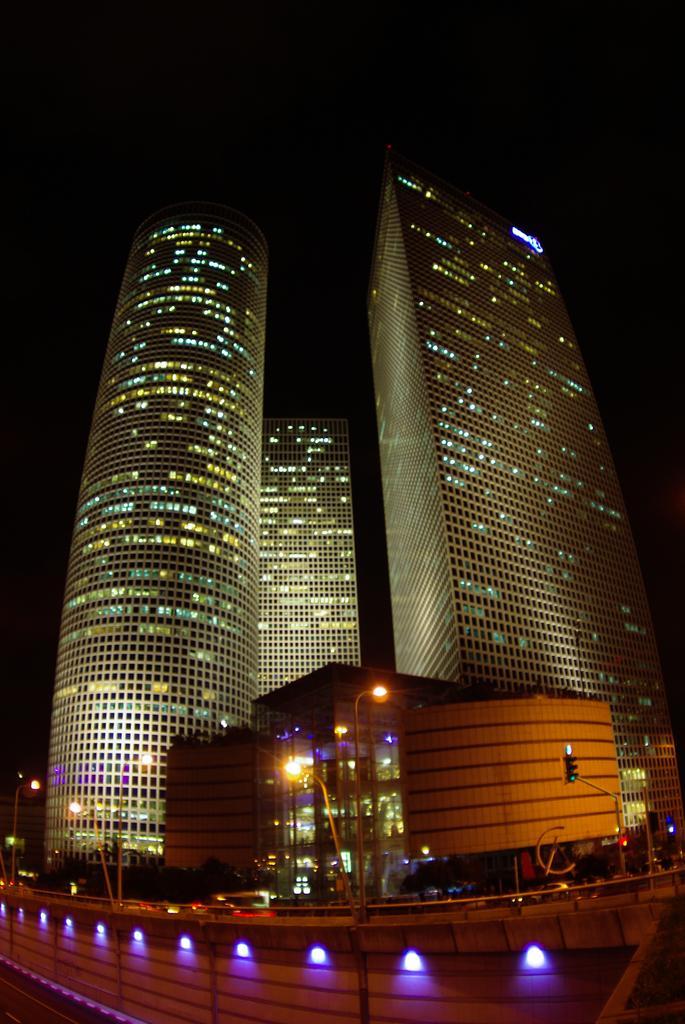In one or two sentences, can you explain what this image depicts? In the image I can see buildings, traffic lights, pole lights, fence and vehicles on the road. In the background I can see the sky and some other objects. 